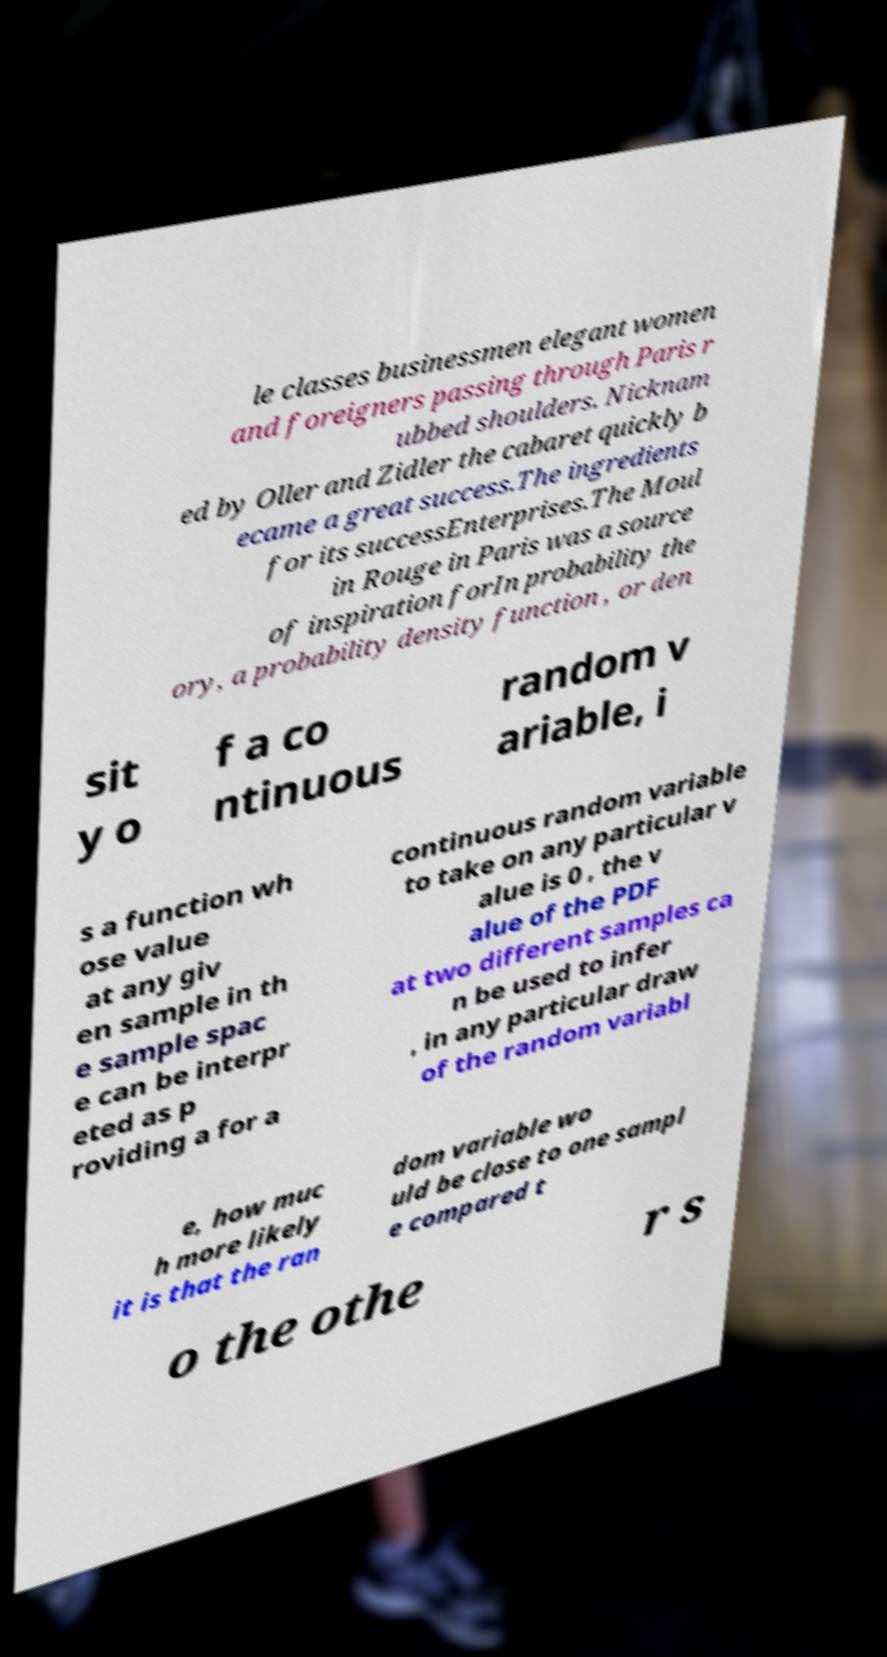Please identify and transcribe the text found in this image. le classes businessmen elegant women and foreigners passing through Paris r ubbed shoulders. Nicknam ed by Oller and Zidler the cabaret quickly b ecame a great success.The ingredients for its successEnterprises.The Moul in Rouge in Paris was a source of inspiration forIn probability the ory, a probability density function , or den sit y o f a co ntinuous random v ariable, i s a function wh ose value at any giv en sample in th e sample spac e can be interpr eted as p roviding a for a continuous random variable to take on any particular v alue is 0 , the v alue of the PDF at two different samples ca n be used to infer , in any particular draw of the random variabl e, how muc h more likely it is that the ran dom variable wo uld be close to one sampl e compared t o the othe r s 